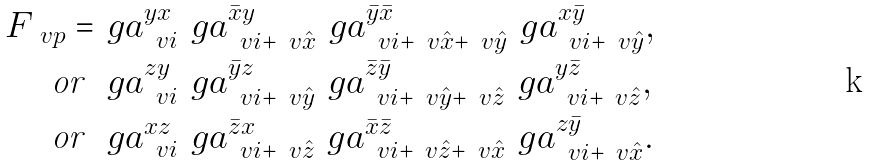<formula> <loc_0><loc_0><loc_500><loc_500>F _ { \ v p } = & \ g a ^ { y x } _ { \ v i } \ g a ^ { \bar { x } y } _ { \ v i + \ v { \hat { x } } } \ g a ^ { \bar { y } \bar { x } } _ { \ v { i } + \ v { \hat { x } } + \ v { \hat { y } } } \ g a ^ { x \bar { y } } _ { \ v i + \ v { \hat { y } } } , \\ \text {or} \ & \ g a ^ { z y } _ { \ v i } \ g a ^ { \bar { y } z } _ { \ v i + \ v { \hat { y } } } \ g a ^ { \bar { z } \bar { y } } _ { \ v i + \ v { \hat { y } } + \ v { \hat { z } } } \ g a ^ { y \bar { z } } _ { \ v i + \ v { \hat { z } } } , \\ \text {or} \ & \ g a ^ { x z } _ { \ v i } \ g a ^ { \bar { z } x } _ { \ v i + \ v { \hat { z } } } \ g a ^ { \bar { x } \bar { z } } _ { \ v i + \ v { \hat { z } } + \ v { \hat { x } } } \ g a ^ { z \bar { y } } _ { \ v i + \ v { \hat { x } } } .</formula> 